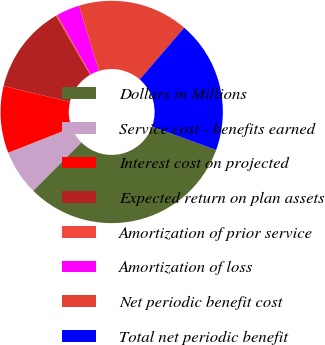<chart> <loc_0><loc_0><loc_500><loc_500><pie_chart><fcel>Dollars in Millions<fcel>Service cost - benefits earned<fcel>Interest cost on projected<fcel>Expected return on plan assets<fcel>Amortization of prior service<fcel>Amortization of loss<fcel>Net periodic benefit cost<fcel>Total net periodic benefit<nl><fcel>31.93%<fcel>6.55%<fcel>9.72%<fcel>12.9%<fcel>0.21%<fcel>3.38%<fcel>16.07%<fcel>19.24%<nl></chart> 